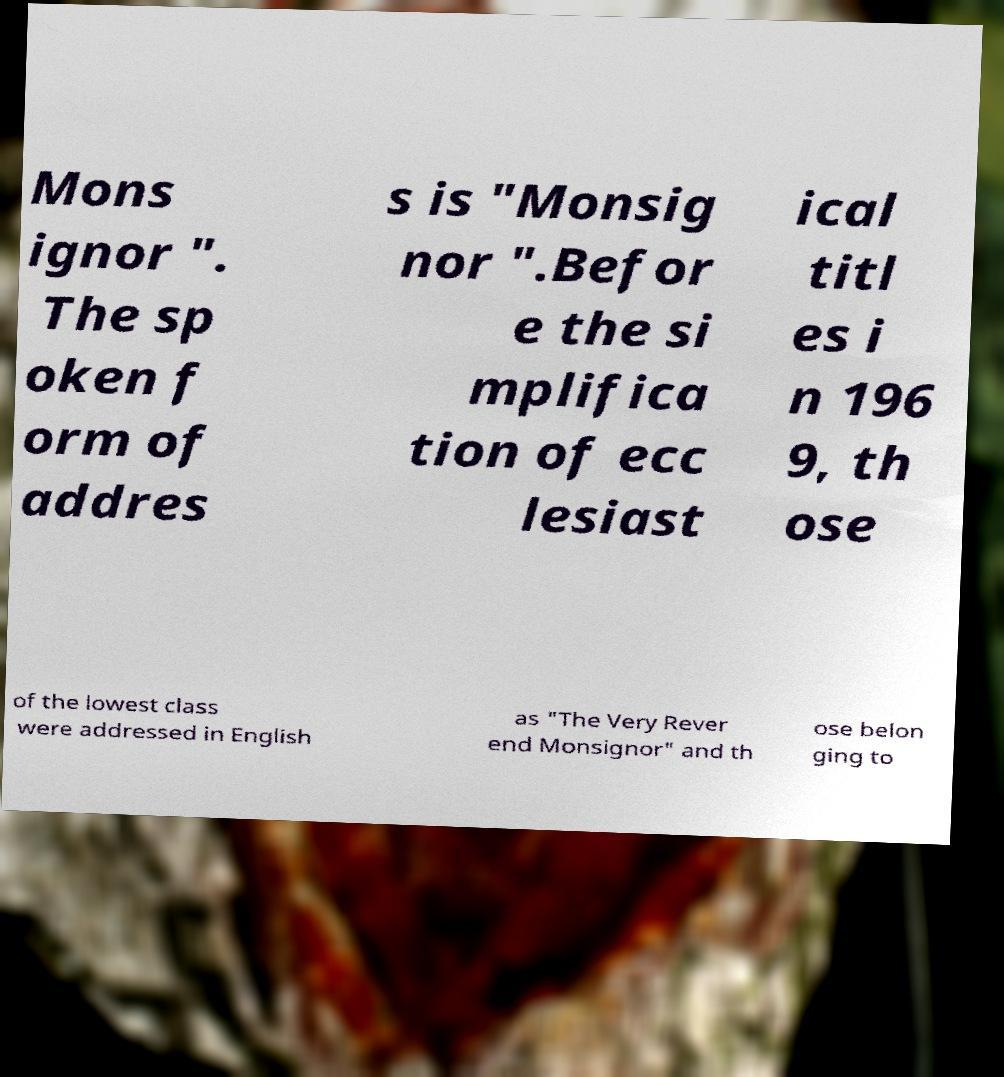Could you assist in decoding the text presented in this image and type it out clearly? Mons ignor ". The sp oken f orm of addres s is "Monsig nor ".Befor e the si mplifica tion of ecc lesiast ical titl es i n 196 9, th ose of the lowest class were addressed in English as "The Very Rever end Monsignor" and th ose belon ging to 